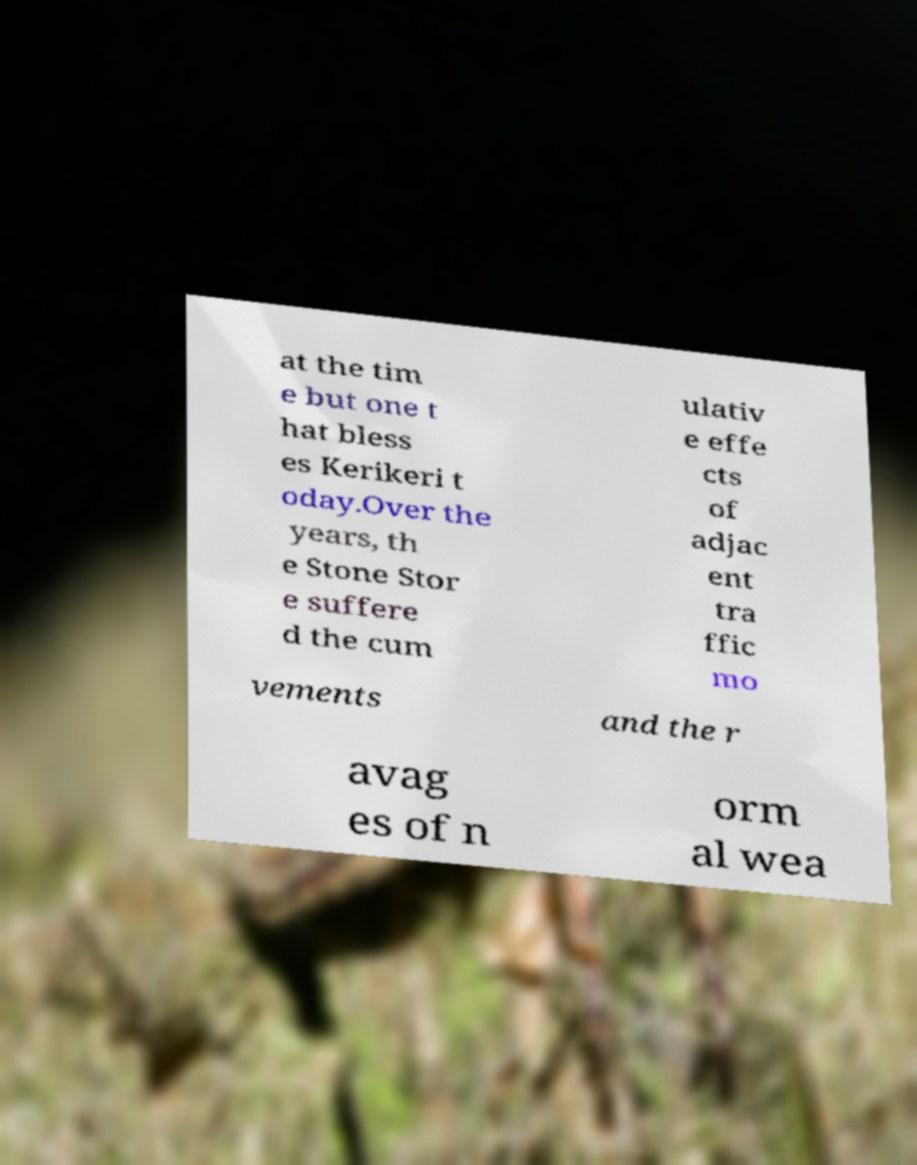Please read and relay the text visible in this image. What does it say? at the tim e but one t hat bless es Kerikeri t oday.Over the years, th e Stone Stor e suffere d the cum ulativ e effe cts of adjac ent tra ffic mo vements and the r avag es of n orm al wea 